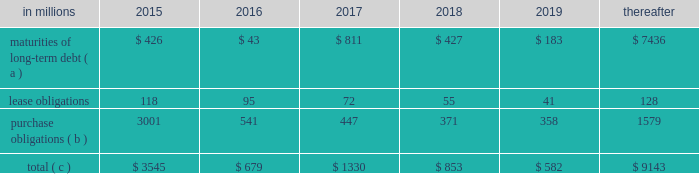The company will continue to rely upon debt and capital markets for the majority of any necessary long-term funding not provided by operating cash flows .
Funding decisions will be guided by our capital structure planning objectives .
The primary goals of the company 2019s capital structure planning are to maximize financial flexibility and preserve liquidity while reducing interest expense .
The majority of international paper 2019s debt is accessed through global public capital markets where we have a wide base of investors .
Maintaining an investment grade credit rating is an important element of international paper 2019s financing strategy .
At december 31 , 2015 , the company held long-term credit ratings of bbb ( stable outlook ) and baa2 ( stable outlook ) by s&p and moody 2019s , respectively .
Contractual obligations for future payments under existing debt and lease commitments and purchase obligations at december 31 , 2015 , were as follows: .
( a ) total debt includes scheduled principal payments only .
( b ) includes $ 2.1 billion relating to fiber supply agreements entered into at the time of the 2006 transformation plan forestland sales and in conjunction with the 2008 acquisition of weyerhaeuser company 2019s containerboard , packaging and recycling business .
( c ) not included in the above table due to the uncertainty as to the amount and timing of the payment are unrecognized tax benefits of approximately $ 101 million .
We consider the undistributed earnings of our foreign subsidiaries as of december 31 , 2015 , to be indefinitely reinvested and , accordingly , no u.s .
Income taxes have been provided thereon .
As of december 31 , 2015 , the amount of cash associated with indefinitely reinvested foreign earnings was approximately $ 600 million .
We do not anticipate the need to repatriate funds to the united states to satisfy domestic liquidity needs arising in the ordinary course of business , including liquidity needs associated with our domestic debt service requirements .
Pension obligations and funding at december 31 , 2015 , the projected benefit obligation for the company 2019s u.s .
Defined benefit plans determined under u.s .
Gaap was approximately $ 3.5 billion higher than the fair value of plan assets .
Approximately $ 3.2 billion of this amount relates to plans that are subject to minimum funding requirements .
Under current irs funding rules , the calculation of minimum funding requirements differs from the calculation of the present value of plan benefits ( the projected benefit obligation ) for accounting purposes .
In december 2008 , the worker , retiree and employer recovery act of 2008 ( wera ) was passed by the u.s .
Congress which provided for pension funding relief and technical corrections .
Funding contributions depend on the funding method selected by the company , and the timing of its implementation , as well as on actual demographic data and the targeted funding level .
The company continually reassesses the amount and timing of any discretionary contributions and elected to make contributions totaling $ 750 million and $ 353 million for the years ended december 31 , 2015 and 2014 , respectively .
At this time , we do not expect to have any required contributions to our plans in 2016 , although the company may elect to make future voluntary contributions .
The timing and amount of future contributions , which could be material , will depend on a number of factors , including the actual earnings and changes in values of plan assets and changes in interest rates .
International paper has announced a voluntary , limited-time opportunity for former employees who are participants in the retirement plan of international paper company ( the pension plan ) to request early payment of their entire pension plan benefit in the form of a single lump sum payment .
Eligible participants who wish to receive the lump sum payment must make an election between february 29 and april 29 , 2016 , and payment is scheduled to be made on or before june 30 , 2016 .
All payments will be made from the pension plan trust assets .
The target population has a total liability of $ 3.0 billion .
The amount of the total payments will depend on the participation rate of eligible participants , but is expected to be approximately $ 1.5 billion .
Based on the expected level of payments , settlement accounting rules will apply in the period in which the payments are made .
This will result in a plan remeasurement and the recognition in earnings of a pro-rata portion of unamortized net actuarial loss .
Ilim holding s.a .
Shareholder 2019s agreement in october 2007 , in connection with the formation of the ilim holding s.a .
Joint venture , international paper entered into a shareholder 2019s agreement that includes provisions relating to the reconciliation of disputes among the partners .
This agreement was amended on may 7 , 2014 .
Pursuant to the amended agreement , beginning on january 1 , 2017 , either the company or its partners may commence certain procedures specified under the deadlock provisions .
If these or any other deadlock provisions are commenced , the company may in certain situations , choose to purchase its partners 2019 50% ( 50 % ) interest in ilim .
Any such transaction would be subject to review and approval by russian and other relevant antitrust authorities .
Any such purchase by international paper would result in the consolidation of ilim 2019s financial position and results of operations in all subsequent periods. .
What percentage of contractual obligations for future payments under existing debt and lease commitments and purchase obligations at december 31 , 2015 are due to maturities of long-term debt in 2017? 
Computations: (811 / 1330)
Answer: 0.60977. 